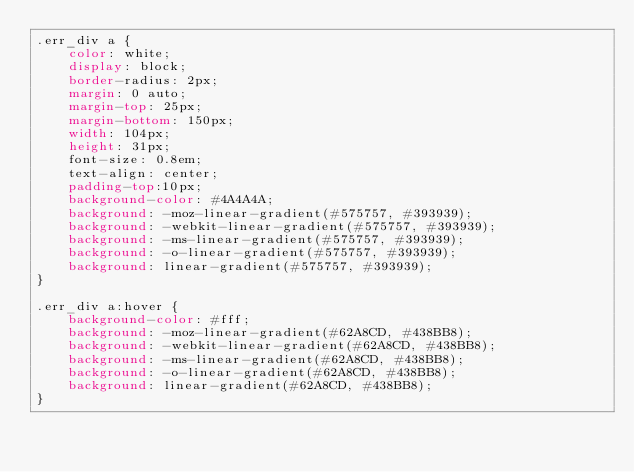Convert code to text. <code><loc_0><loc_0><loc_500><loc_500><_CSS_>.err_div a {
    color: white;
    display: block;
    border-radius: 2px;
    margin: 0 auto;
    margin-top: 25px;
    margin-bottom: 150px;
    width: 104px;
    height: 31px;
    font-size: 0.8em;
    text-align: center;
    padding-top:10px;
    background-color: #4A4A4A;
    background: -moz-linear-gradient(#575757, #393939);
    background: -webkit-linear-gradient(#575757, #393939);
    background: -ms-linear-gradient(#575757, #393939);
    background: -o-linear-gradient(#575757, #393939);
    background: linear-gradient(#575757, #393939);
}

.err_div a:hover {
    background-color: #fff;
    background: -moz-linear-gradient(#62A8CD, #438BB8);
    background: -webkit-linear-gradient(#62A8CD, #438BB8);
    background: -ms-linear-gradient(#62A8CD, #438BB8);
    background: -o-linear-gradient(#62A8CD, #438BB8);
    background: linear-gradient(#62A8CD, #438BB8);
}</code> 